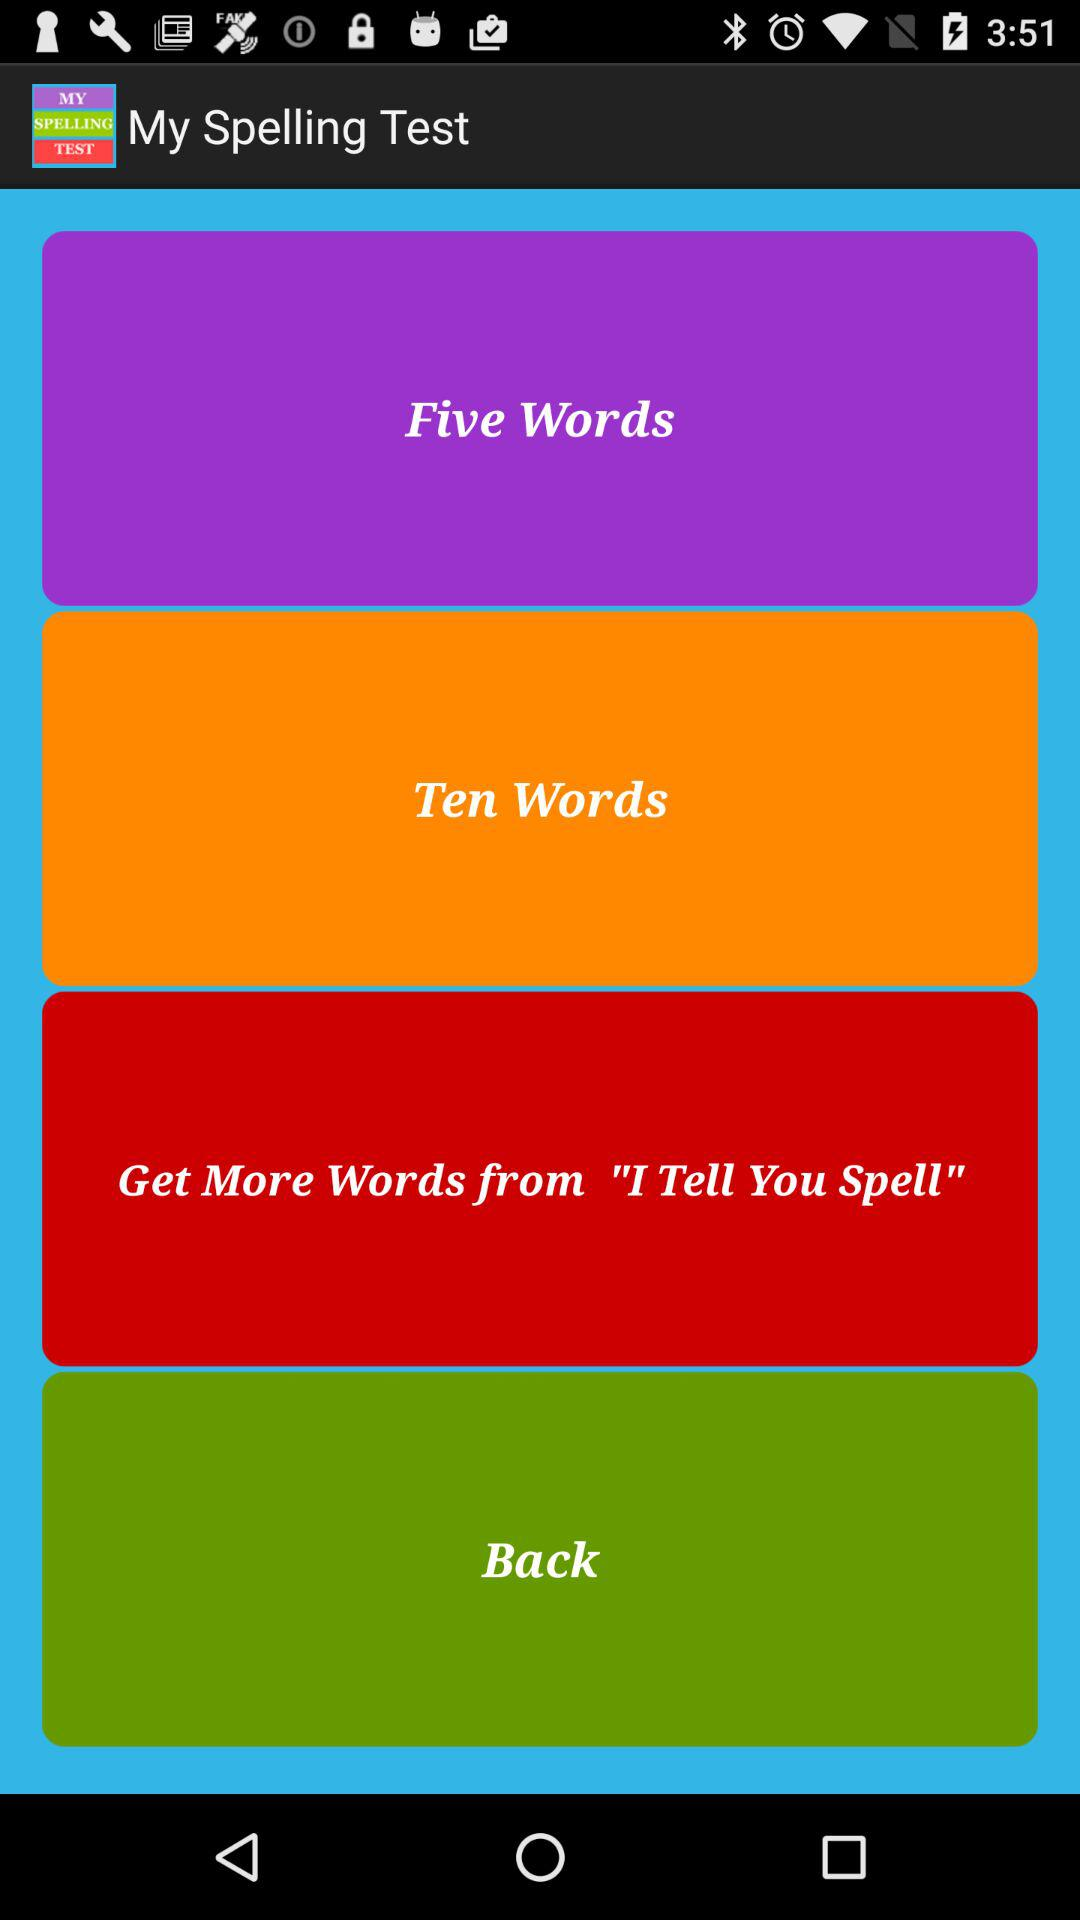What is the name of the application? The application name is "My Spelling Test". 